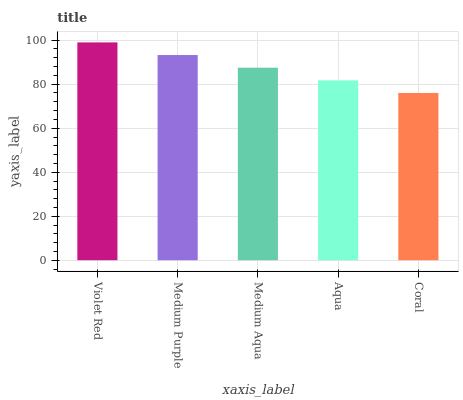Is Medium Purple the minimum?
Answer yes or no. No. Is Medium Purple the maximum?
Answer yes or no. No. Is Violet Red greater than Medium Purple?
Answer yes or no. Yes. Is Medium Purple less than Violet Red?
Answer yes or no. Yes. Is Medium Purple greater than Violet Red?
Answer yes or no. No. Is Violet Red less than Medium Purple?
Answer yes or no. No. Is Medium Aqua the high median?
Answer yes or no. Yes. Is Medium Aqua the low median?
Answer yes or no. Yes. Is Aqua the high median?
Answer yes or no. No. Is Coral the low median?
Answer yes or no. No. 